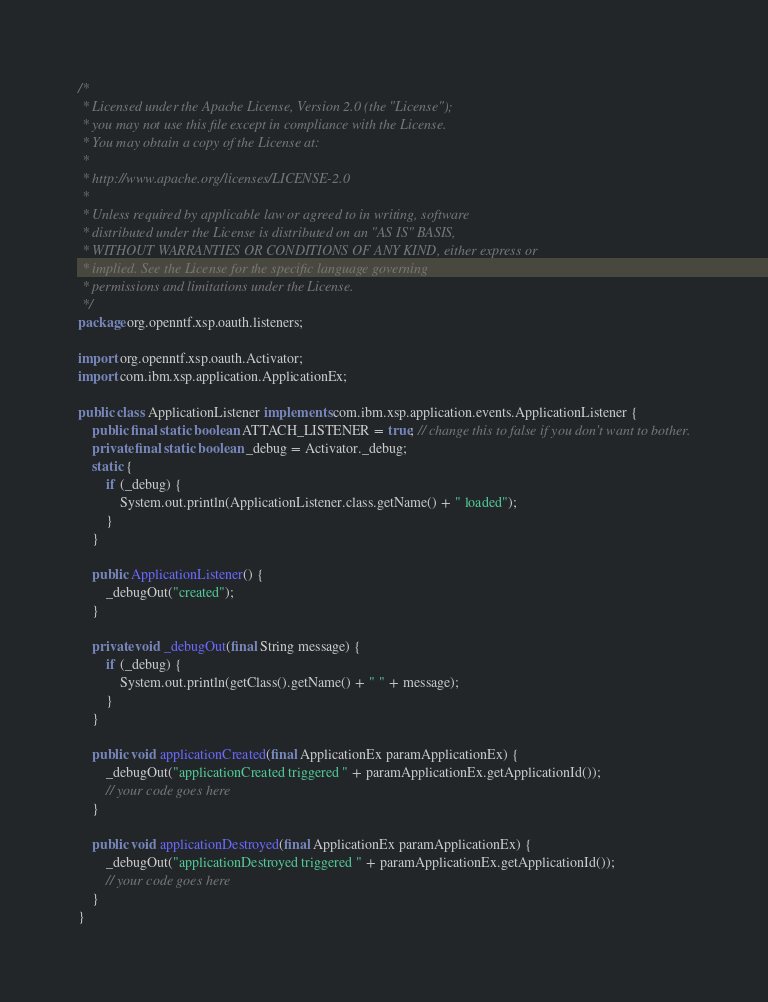Convert code to text. <code><loc_0><loc_0><loc_500><loc_500><_Java_>/*
 * Licensed under the Apache License, Version 2.0 (the "License"); 
 * you may not use this file except in compliance with the License. 
 * You may obtain a copy of the License at:
 * 
 * http://www.apache.org/licenses/LICENSE-2.0 
 * 
 * Unless required by applicable law or agreed to in writing, software 
 * distributed under the License is distributed on an "AS IS" BASIS, 
 * WITHOUT WARRANTIES OR CONDITIONS OF ANY KIND, either express or 
 * implied. See the License for the specific language governing 
 * permissions and limitations under the License.
 */
package org.openntf.xsp.oauth.listeners;

import org.openntf.xsp.oauth.Activator;
import com.ibm.xsp.application.ApplicationEx;

public class ApplicationListener implements com.ibm.xsp.application.events.ApplicationListener {
	public final static boolean ATTACH_LISTENER = true; // change this to false if you don't want to bother.
	private final static boolean _debug = Activator._debug;
	static {
		if (_debug) {
			System.out.println(ApplicationListener.class.getName() + " loaded");
		}
	}

	public ApplicationListener() {
		_debugOut("created");
	}

	private void _debugOut(final String message) {
		if (_debug) {
			System.out.println(getClass().getName() + " " + message);
		}
	}

	public void applicationCreated(final ApplicationEx paramApplicationEx) {
		_debugOut("applicationCreated triggered " + paramApplicationEx.getApplicationId());
		// your code goes here
	}

	public void applicationDestroyed(final ApplicationEx paramApplicationEx) {
		_debugOut("applicationDestroyed triggered " + paramApplicationEx.getApplicationId());
		// your code goes here
	}
}
</code> 